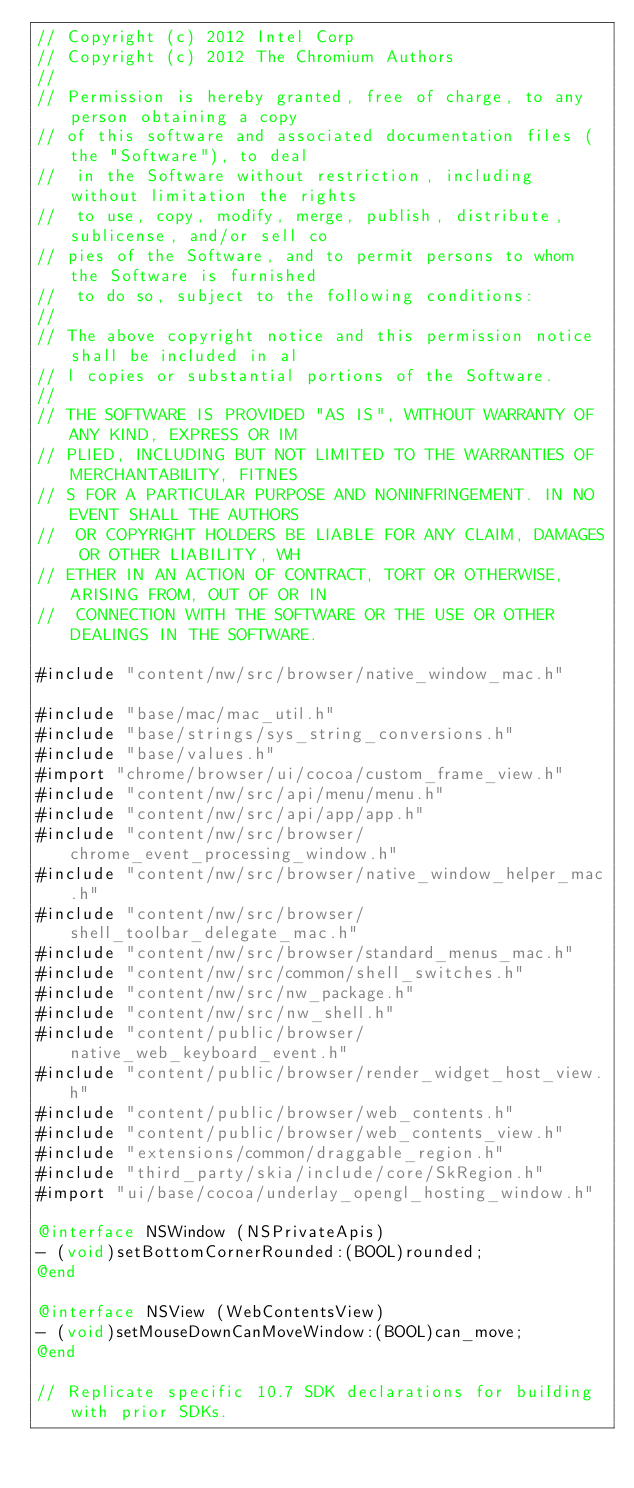Convert code to text. <code><loc_0><loc_0><loc_500><loc_500><_ObjectiveC_>// Copyright (c) 2012 Intel Corp
// Copyright (c) 2012 The Chromium Authors
//
// Permission is hereby granted, free of charge, to any person obtaining a copy
// of this software and associated documentation files (the "Software"), to deal
//  in the Software without restriction, including without limitation the rights
//  to use, copy, modify, merge, publish, distribute, sublicense, and/or sell co
// pies of the Software, and to permit persons to whom the Software is furnished
//  to do so, subject to the following conditions:
//
// The above copyright notice and this permission notice shall be included in al
// l copies or substantial portions of the Software.
//
// THE SOFTWARE IS PROVIDED "AS IS", WITHOUT WARRANTY OF ANY KIND, EXPRESS OR IM
// PLIED, INCLUDING BUT NOT LIMITED TO THE WARRANTIES OF MERCHANTABILITY, FITNES
// S FOR A PARTICULAR PURPOSE AND NONINFRINGEMENT. IN NO EVENT SHALL THE AUTHORS
//  OR COPYRIGHT HOLDERS BE LIABLE FOR ANY CLAIM, DAMAGES OR OTHER LIABILITY, WH
// ETHER IN AN ACTION OF CONTRACT, TORT OR OTHERWISE, ARISING FROM, OUT OF OR IN
//  CONNECTION WITH THE SOFTWARE OR THE USE OR OTHER DEALINGS IN THE SOFTWARE.

#include "content/nw/src/browser/native_window_mac.h"

#include "base/mac/mac_util.h"
#include "base/strings/sys_string_conversions.h"
#include "base/values.h"
#import "chrome/browser/ui/cocoa/custom_frame_view.h"
#include "content/nw/src/api/menu/menu.h"
#include "content/nw/src/api/app/app.h"
#include "content/nw/src/browser/chrome_event_processing_window.h"
#include "content/nw/src/browser/native_window_helper_mac.h"
#include "content/nw/src/browser/shell_toolbar_delegate_mac.h"
#include "content/nw/src/browser/standard_menus_mac.h"
#include "content/nw/src/common/shell_switches.h"
#include "content/nw/src/nw_package.h"
#include "content/nw/src/nw_shell.h"
#include "content/public/browser/native_web_keyboard_event.h"
#include "content/public/browser/render_widget_host_view.h"
#include "content/public/browser/web_contents.h"
#include "content/public/browser/web_contents_view.h"
#include "extensions/common/draggable_region.h"
#include "third_party/skia/include/core/SkRegion.h"
#import "ui/base/cocoa/underlay_opengl_hosting_window.h"

@interface NSWindow (NSPrivateApis)
- (void)setBottomCornerRounded:(BOOL)rounded;
@end

@interface NSView (WebContentsView)
- (void)setMouseDownCanMoveWindow:(BOOL)can_move;
@end

// Replicate specific 10.7 SDK declarations for building with prior SDKs.</code> 